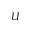<formula> <loc_0><loc_0><loc_500><loc_500>U</formula> 